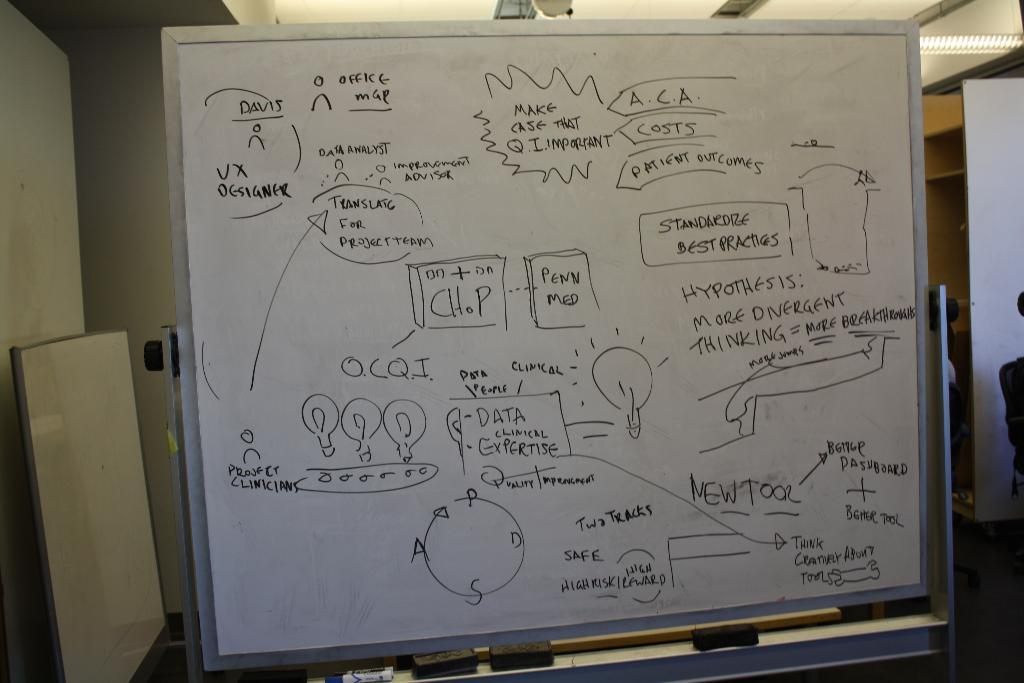<image>
Present a compact description of the photo's key features. A white marker board with several graphs and flow charts with text that says make case that q.i. important at the top. 